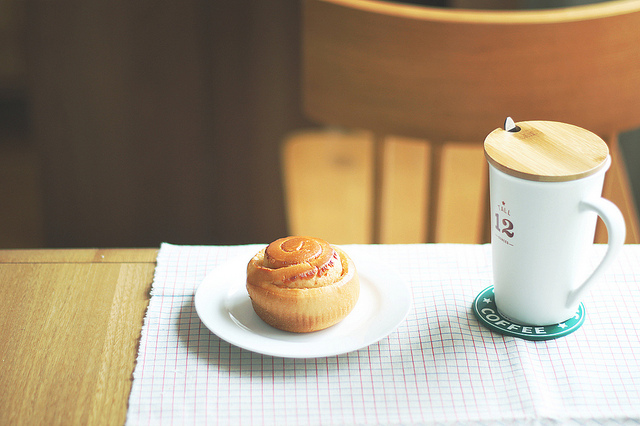<image>What brand of coffee is this? I don't know the brand of coffee. It can be either Starbucks or Folgers. What brand of coffee is this? I don't know what brand of coffee it is. It could be either Folgers or Starbucks. 